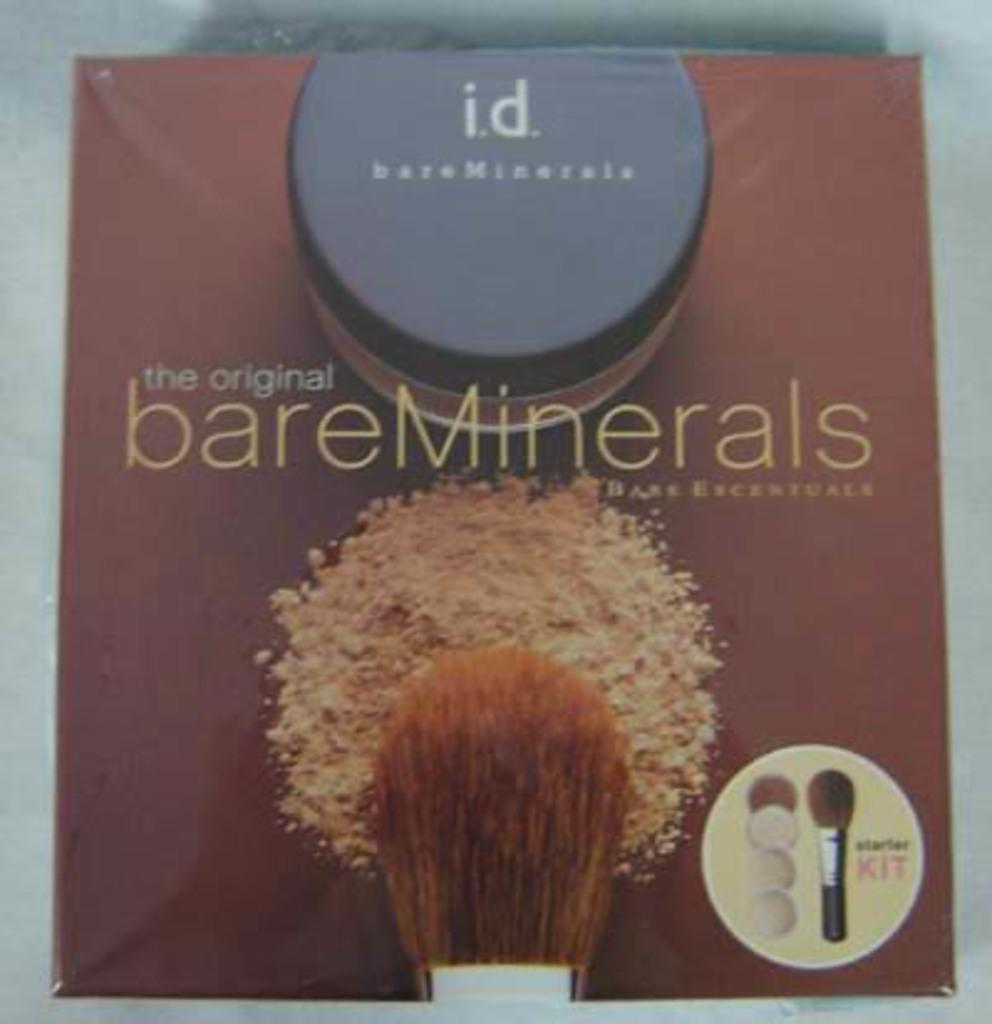<image>
Describe the image concisely. A bare minerals ad shows a brush and a container of the product. 